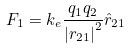<formula> <loc_0><loc_0><loc_500><loc_500>F _ { 1 } = k _ { e } \frac { q _ { 1 } q _ { 2 } } { { | r _ { 2 1 } | } ^ { 2 } } \hat { r } _ { 2 1 }</formula> 